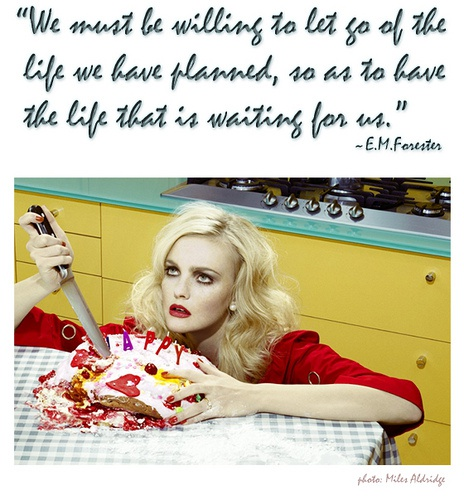Describe the objects in this image and their specific colors. I can see people in white, beige, tan, and maroon tones, dining table in white, darkgray, lightgray, and lightpink tones, oven in white, black, teal, darkgray, and gray tones, cake in white, brown, lightpink, and maroon tones, and knife in white, darkgray, gray, tan, and brown tones in this image. 